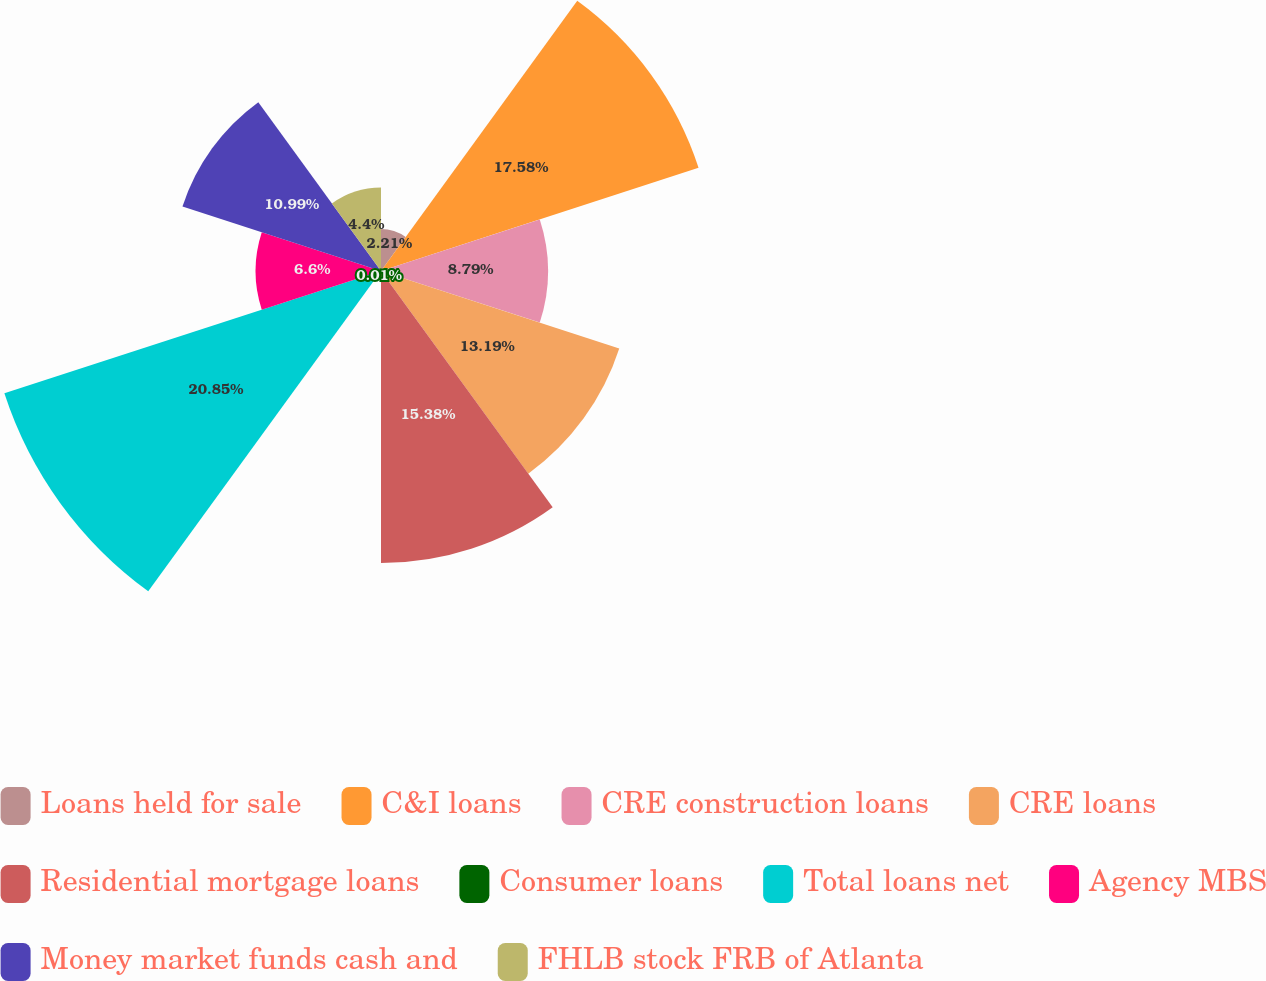Convert chart. <chart><loc_0><loc_0><loc_500><loc_500><pie_chart><fcel>Loans held for sale<fcel>C&I loans<fcel>CRE construction loans<fcel>CRE loans<fcel>Residential mortgage loans<fcel>Consumer loans<fcel>Total loans net<fcel>Agency MBS<fcel>Money market funds cash and<fcel>FHLB stock FRB of Atlanta<nl><fcel>2.21%<fcel>17.58%<fcel>8.79%<fcel>13.19%<fcel>15.38%<fcel>0.01%<fcel>20.85%<fcel>6.6%<fcel>10.99%<fcel>4.4%<nl></chart> 